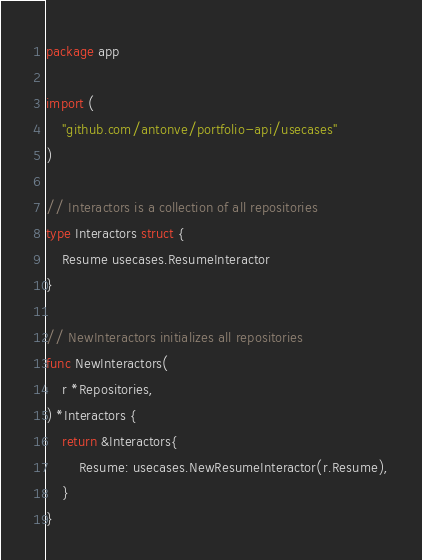<code> <loc_0><loc_0><loc_500><loc_500><_Go_>package app

import (
	"github.com/antonve/portfolio-api/usecases"
)

// Interactors is a collection of all repositories
type Interactors struct {
	Resume usecases.ResumeInteractor
}

// NewInteractors initializes all repositories
func NewInteractors(
	r *Repositories,
) *Interactors {
	return &Interactors{
		Resume: usecases.NewResumeInteractor(r.Resume),
	}
}
</code> 